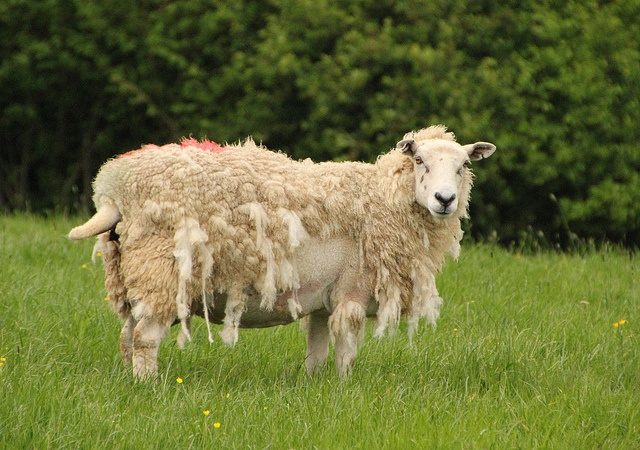Describe the objects in this image and their specific colors. I can see a sheep in darkgreen, tan, and gray tones in this image. 